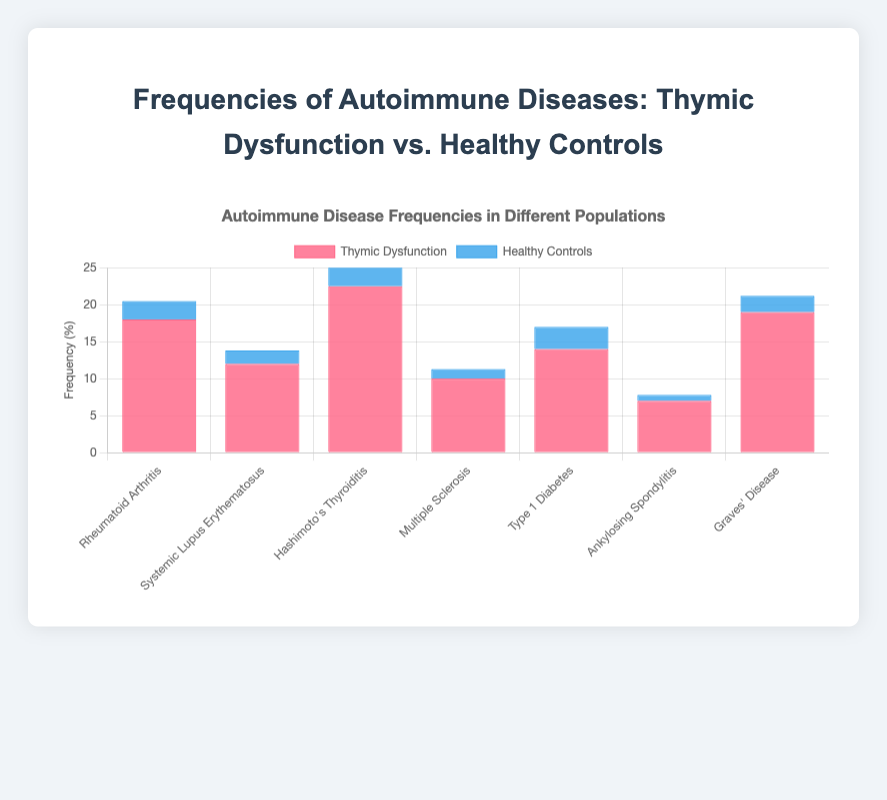What percentage of the population with thymic dysfunction has Hashimoto's Thyroiditis, and how does this compare to healthy controls? The bar chart shows the frequency of Hashimoto's Thyroiditis is 22.5% for thymic dysfunction and 4.5% for healthy controls. The difference is 22.5% - 4.5% = 18%.
Answer: 22.5% (Thymic Dysfunction) and 4.5% (Healthy Controls) Which autoimmune disease shows the largest difference in frequency between populations with thymic dysfunction and healthy controls? For each autoimmune disease, compute the difference: Rheumatoid Arthritis (15.5%), Systemic Lupus Erythematosus (10.2%), Hashimoto's Thyroiditis (18.0%), Multiple Sclerosis (8.7%), Type 1 Diabetes (11.0%), Ankylosing Spondylitis (6.2%), Graves' Disease (16.8%). The largest difference is for Hashimoto's Thyroiditis with 18.0%.
Answer: Hashimoto's Thyroiditis How many autoimmune diseases show a frequency of over 10% in the thymic dysfunction group? Examine the bars representing thymic dysfunction: Rheumatoid Arthritis (18.0%), Systemic Lupus Erythematosus (12.0%), Hashimoto's Thyroiditis (22.5%), Multiple Sclerosis (10.0%), Type 1 Diabetes (14.0%), Ankylosing Spondylitis (7.0%), Graves' Disease (19.0%). Six diseases are above 10%.
Answer: 6 What's the frequency difference between the two populations for Multiple Sclerosis? For Multiple Sclerosis, thymic dysfunction has 10.0%, and healthy controls have 1.3%. The difference is 10.0% - 1.3% = 8.7%.
Answer: 8.7% Which group has the higher prevalence of Type 1 Diabetes, and by how much? The bar chart shows Type 1 Diabetes frequency is 14.0% in the thymic dysfunction group and 3.0% in the healthy controls group, so thymic dysfunction has a higher prevalence by 14.0% - 3.0% = 11.0%.
Answer: Thymic Dysfunction by 11.0% Rank the autoimmune diseases from highest to lowest frequency in the thymic dysfunction group. Based on the heights of the bars for thymic dysfunction: Hashimoto's Thyroiditis (22.5%), Graves' Disease (19.0%), Rheumatoid Arthritis (18.0%), Type 1 Diabetes (14.0%), Systemic Lupus Erythematosus (12.0%), Multiple Sclerosis (10.0%), Ankylosing Spondylitis (7.0%).
Answer: Hashimoto's Thyroiditis > Graves' Disease > Rheumatoid Arthritis > Type 1 Diabetes > Systemic Lupus Erythematosus > Multiple Sclerosis > Ankylosing Spondylitis What is the combined frequency of all autoimmune diseases for healthy controls? Add the frequencies for all autoimmune diseases in healthy controls: 2.5% (Rheumatoid Arthritis) + 1.8% (Systemic Lupus Erythematosus) + 4.5% (Hashimoto's Thyroiditis) + 1.3% (Multiple Sclerosis) + 3.0% (Type 1 Diabetes) + 0.8% (Ankylosing Spondylitis) + 2.2% (Graves' Disease). The total is 16.1%.
Answer: 16.1% Which autoimmune disease has the smallest difference in frequency between the two groups? Calculate the difference for each disease: Rheumatoid Arthritis (15.5%), Systemic Lupus Erythematosus (10.2%), Hashimoto's Thyroiditis (18.0%), Multiple Sclerosis (8.7%), Type 1 Diabetes (11.0%), Ankylosing Spondylitis (6.2%), Graves' Disease (16.8%). The smallest difference is for Ankylosing Spondylitis (6.2%).
Answer: Ankylosing Spondylitis 